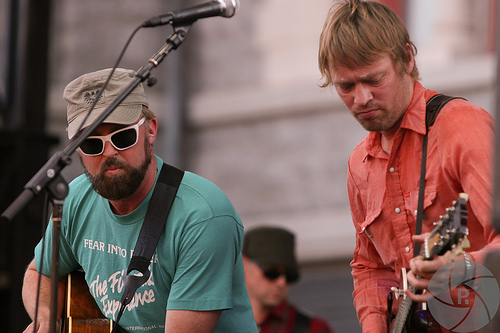<image>
Can you confirm if the red man is to the left of the green man? Yes. From this viewpoint, the red man is positioned to the left side relative to the green man. 